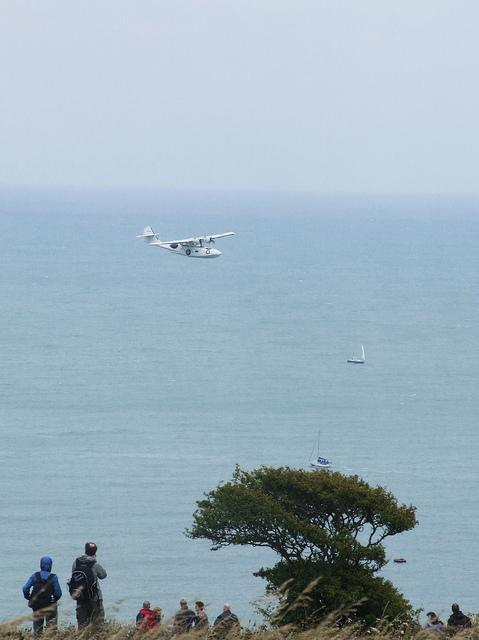Which thing here is the highest?

Choices:
A) train
B) boat
C) airplane
D) car airplane 